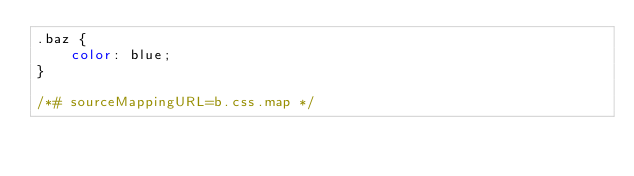Convert code to text. <code><loc_0><loc_0><loc_500><loc_500><_CSS_>.baz {
	color: blue;
}

/*# sourceMappingURL=b.css.map */</code> 